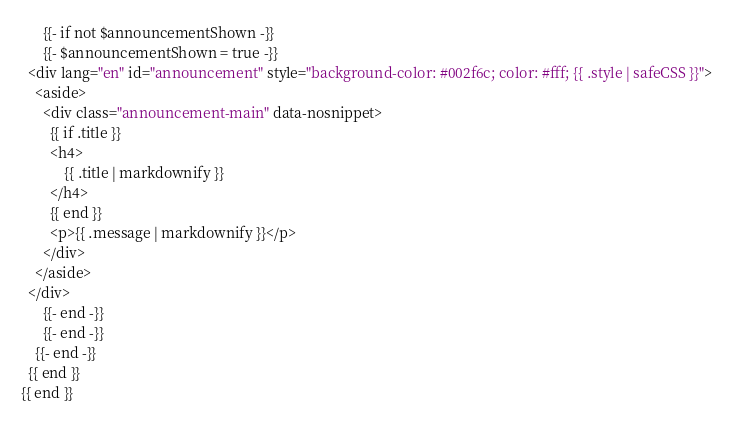<code> <loc_0><loc_0><loc_500><loc_500><_HTML_>      {{- if not $announcementShown -}}
      {{- $announcementShown = true -}}
  <div lang="en" id="announcement" style="background-color: #002f6c; color: #fff; {{ .style | safeCSS }}">
    <aside>
      <div class="announcement-main" data-nosnippet>
        {{ if .title }}
        <h4>
            {{ .title | markdownify }}
        </h4>
        {{ end }}
        <p>{{ .message | markdownify }}</p>
      </div>
    </aside>
  </div>
      {{- end -}}
      {{- end -}}
    {{- end -}}
  {{ end }}
{{ end }}</code> 